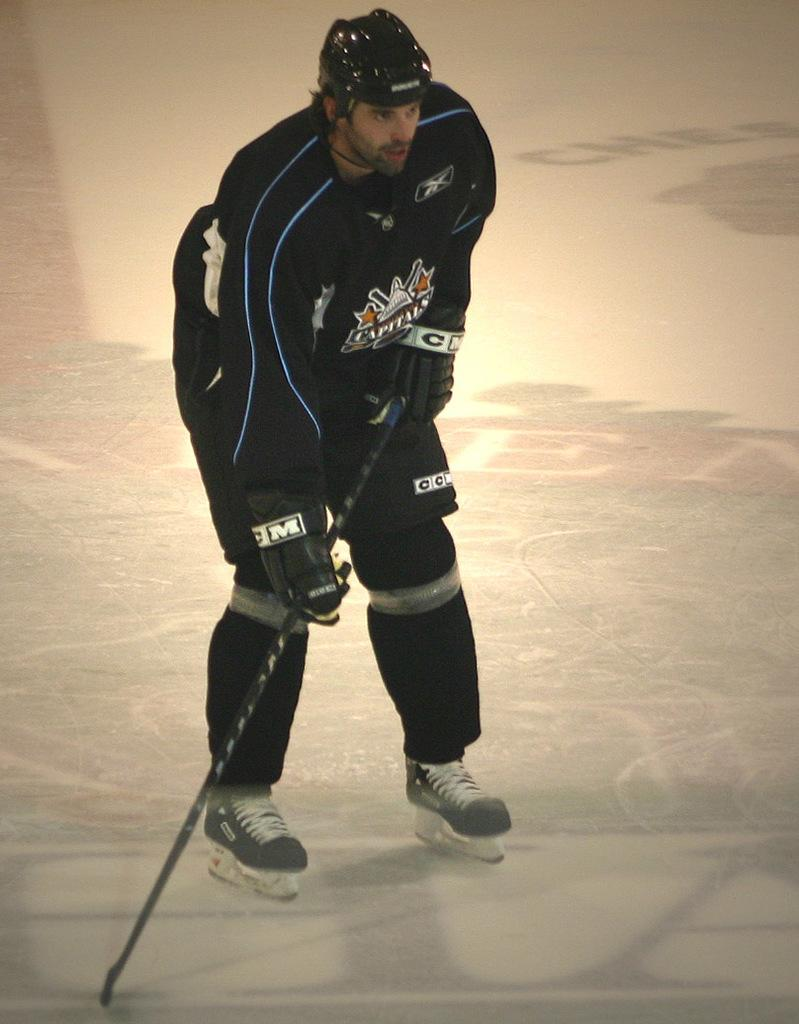What is the person in the image doing? The person is playing ice hockey. What object is the person holding in the image? The person is holding a hockey stick. What type of account is the person opening in the image? There is no account being opened in the image; the person is playing ice hockey. What type of vest is the person wearing in the image? There is no vest visible in the image; the person is wearing ice hockey gear, including a helmet and protective padding. 